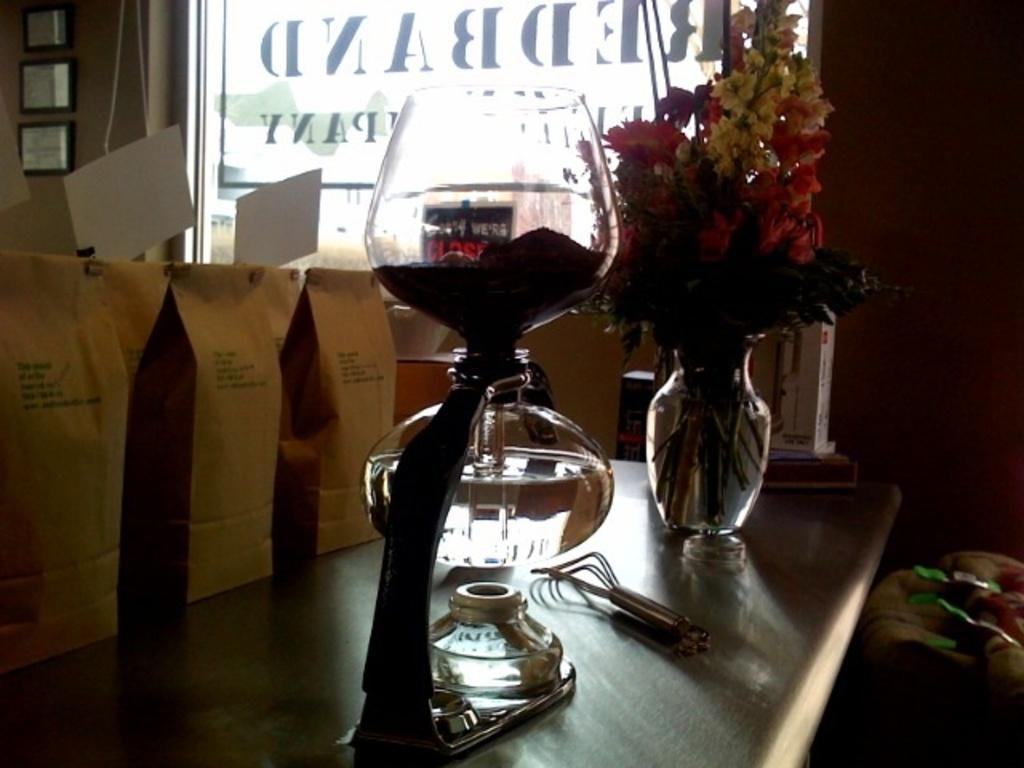What is one object visible on the table in the image? There is a glass on the table in the image. What else is on the table in the image? There is a flower pot on the table in the image. Where are the paper bags located in the image? The paper bags are on the side in the image. What can be seen on the wall in the image? There is a glass and photo frames visible on the wall in the image. How many bears are sitting in the basket in the image? There is no basket or bears present in the image. What type of crow can be seen interacting with the photo frames on the wall? There is no crow present in the image; only the glass and photo frames are visible on the wall. 